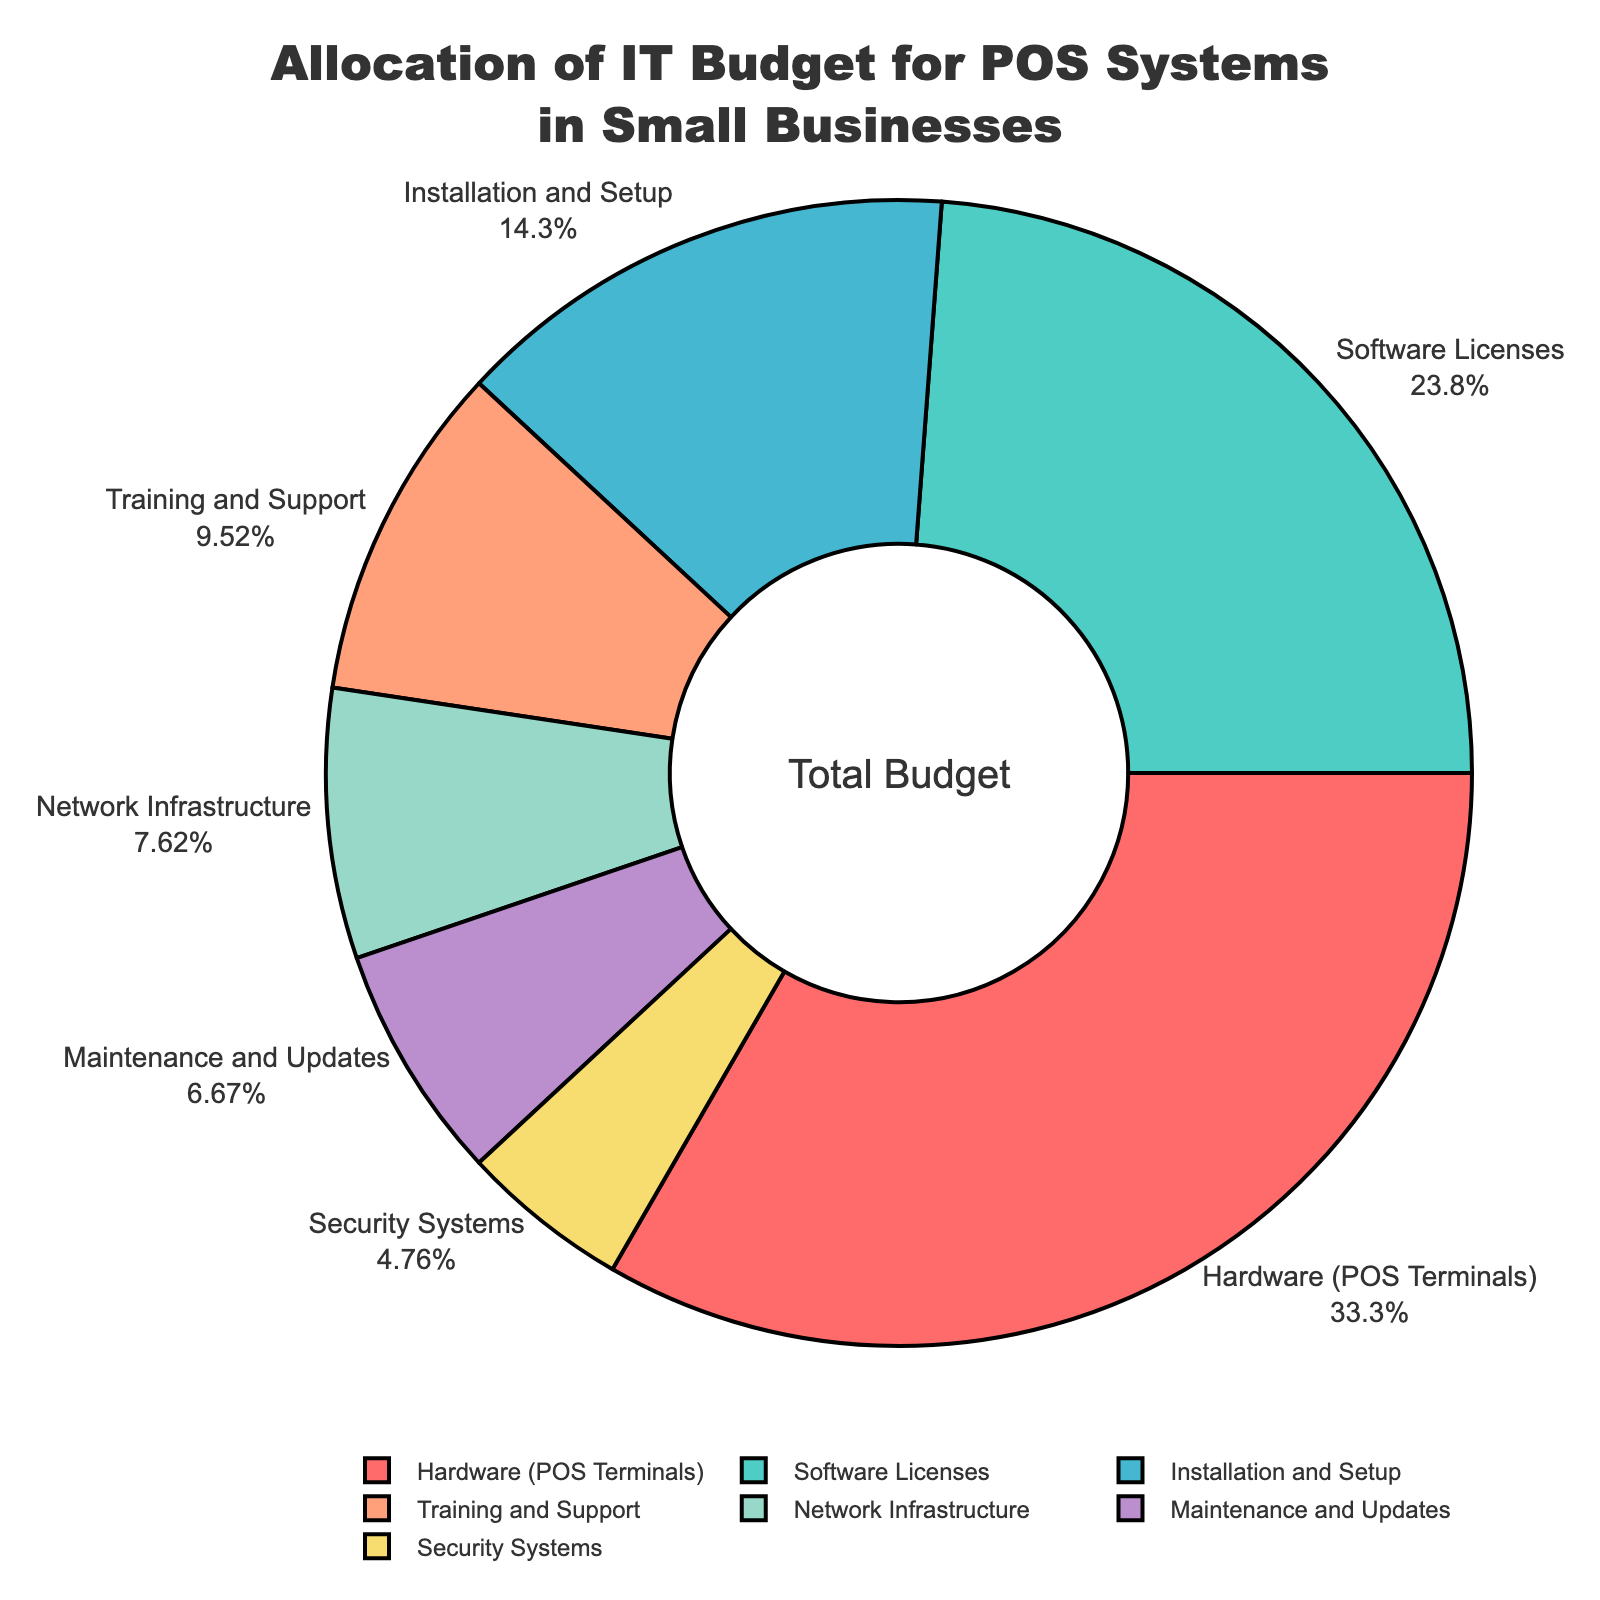What is the largest category in the pie chart? By referring to the pie chart, we can see that the largest segment represents 'Hardware (POS Terminals)' with a percentage of 35%.
Answer: Hardware (POS Terminals) Which two categories together make up half of the IT budget? 'Hardware (POS Terminals)' represents 35% and 'Software Licenses' represents 25%. Summing these percentages, 35% + 25% = 60%, which is more than half. Therefore, it is not these two. We need to find two categories that together make up 50%. Looking further, 'Hardware (POS Terminals)' (35%) and 'Installation and Setup' (15%) together make up 35% + 15% = 50%. These two categories together make up half of the IT budget.
Answer: Hardware (POS Terminals) and Installation and Setup What is the difference in percentage allocation between 'Network Infrastructure' and 'Security Systems'? 'Network Infrastructure' has an 8% allocation and 'Security Systems' has a 5% allocation. The difference between them is calculated as 8% - 5% = 3%.
Answer: 3% What's the combined percentage of 'Training and Support' and 'Maintenance and Updates'? 'Training and Support' has a 10% allocation and 'Maintenance and Updates' has a 7% allocation. Adding them together, we get 10% + 7% = 17%.
Answer: 17% Which category has the smallest percentage, and what is it? By examining the pie chart, 'Security Systems' has the smallest percentage with a value of 5%.
Answer: Security Systems, 5% If you combine 'Software Licenses', 'Installation and Setup', and 'Maintenance and Updates', what percentage of the budget do they represent? 'Software Licenses' is 25%, 'Installation and Setup' is 15%, and 'Maintenance and Updates' is 7%. Adding them together, 25% + 15% + 7% = 47%.
Answer: 47% How much larger is the percentage allocation for 'Software Licenses' compared to 'Training and Support'? 'Software Licenses' has a 25% allocation and 'Training and Support' has a 10% allocation. The difference is calculated as 25% - 10% = 15%.
Answer: 15% Which category has a blue color, and what percentage does it represent? By observing the visual attributes, the segment in blue color represents 'Maintenance and Updates' with a percentage of 7%.
Answer: Maintenance and Updates, 7% What total percentage of the budget is allocated for both 'Network Infrastructure' and 'Security Systems'? 'Network Infrastructure' is 8% and 'Security Systems' is 5%. Adding these percentages together, 8% + 5% = 13%.
Answer: 13% 